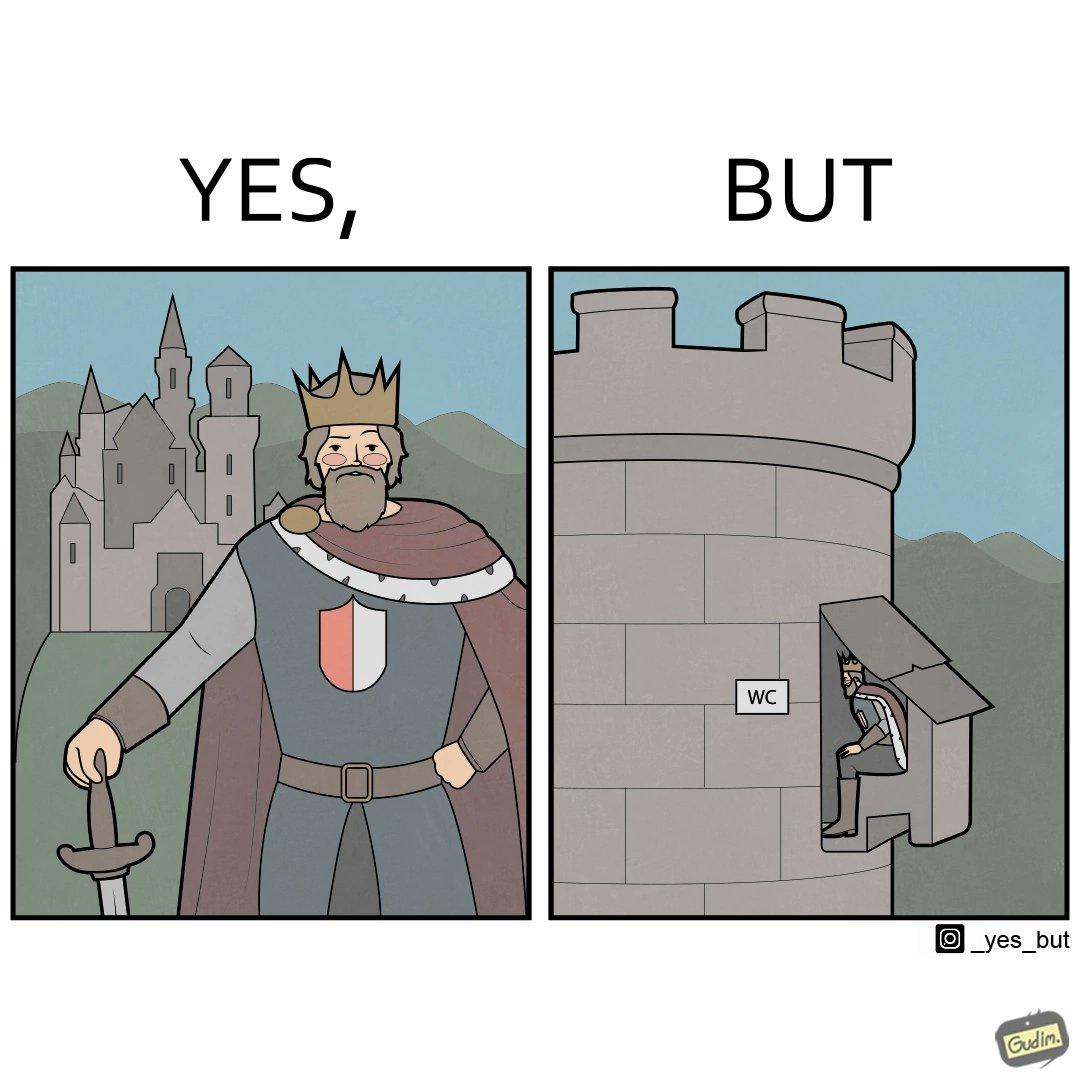What does this image depict? The images are funny since it shows how even a mighty king must do simple things like using a toilet just like everyone else does 